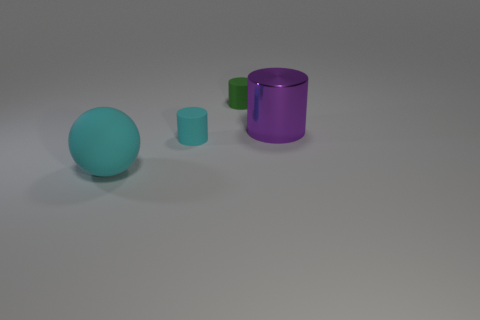Are any purple cylinders visible?
Provide a short and direct response. Yes. How many balls have the same color as the metal cylinder?
Offer a terse response. 0. How big is the rubber cylinder to the right of the tiny matte cylinder in front of the green rubber cylinder?
Provide a short and direct response. Small. Is there a gray thing made of the same material as the green object?
Give a very brief answer. No. There is a purple cylinder that is the same size as the ball; what material is it?
Your response must be concise. Metal. There is a thing that is on the left side of the tiny cyan rubber cylinder; does it have the same color as the tiny cylinder that is left of the green matte cylinder?
Keep it short and to the point. Yes. There is a large object that is on the right side of the green rubber cylinder; are there any cyan cylinders that are behind it?
Keep it short and to the point. No. Is the shape of the small object on the right side of the cyan cylinder the same as the large thing behind the small cyan rubber cylinder?
Offer a very short reply. Yes. Are the small cylinder behind the small cyan thing and the big thing that is on the left side of the big cylinder made of the same material?
Keep it short and to the point. Yes. What is the material of the small cylinder that is to the right of the small matte cylinder in front of the small green rubber object?
Provide a succinct answer. Rubber. 